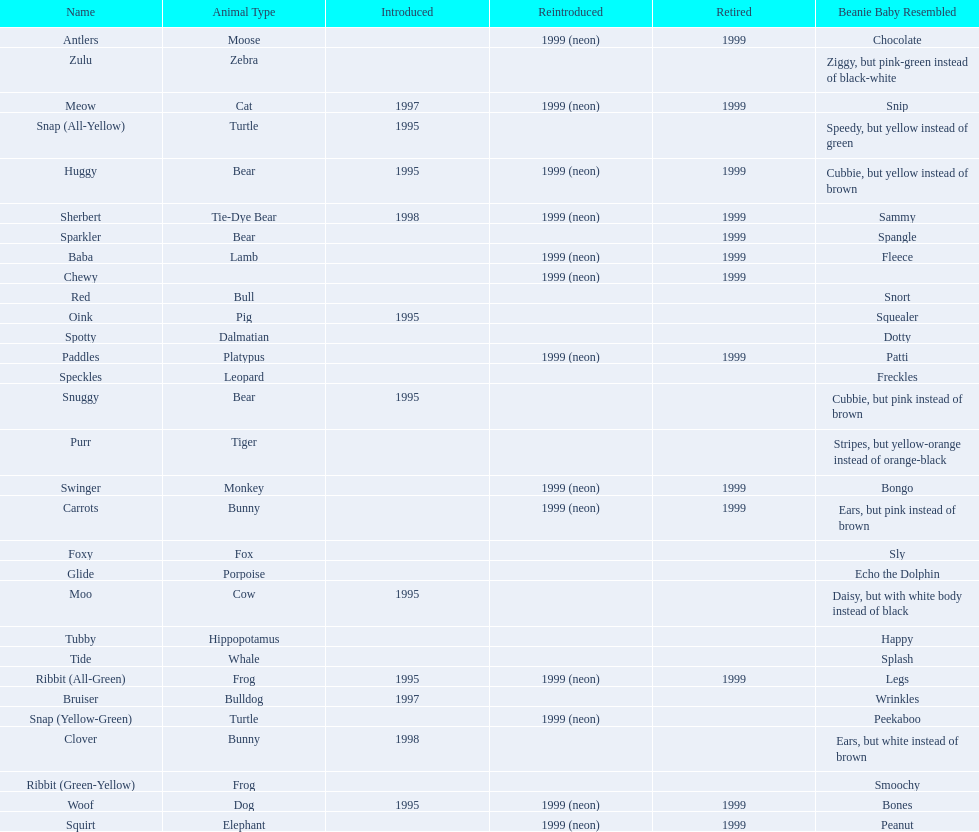What are the total number of pillow pals on this chart? 30. 